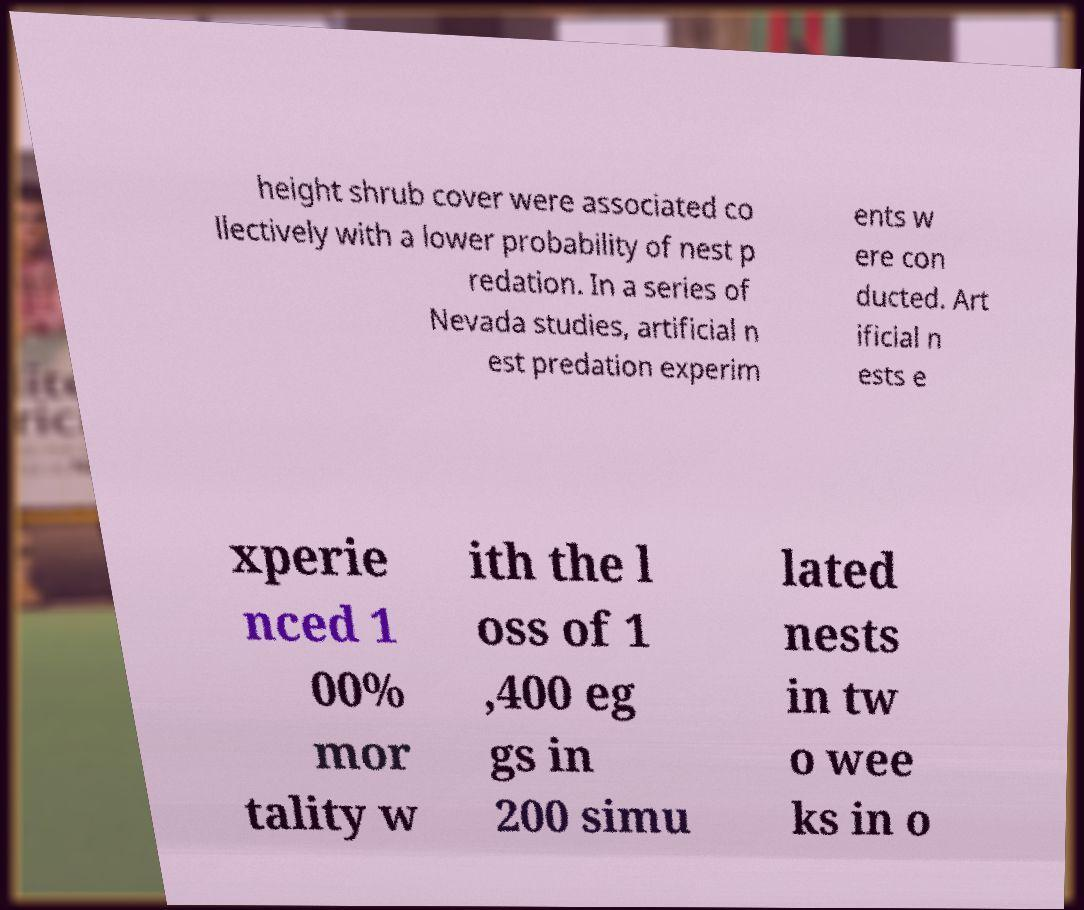Can you read and provide the text displayed in the image?This photo seems to have some interesting text. Can you extract and type it out for me? height shrub cover were associated co llectively with a lower probability of nest p redation. In a series of Nevada studies, artificial n est predation experim ents w ere con ducted. Art ificial n ests e xperie nced 1 00% mor tality w ith the l oss of 1 ,400 eg gs in 200 simu lated nests in tw o wee ks in o 